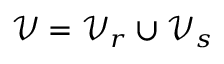Convert formula to latex. <formula><loc_0><loc_0><loc_500><loc_500>\mathcal { V } = \mathcal { V } _ { r } \cup \mathcal { V } _ { s }</formula> 